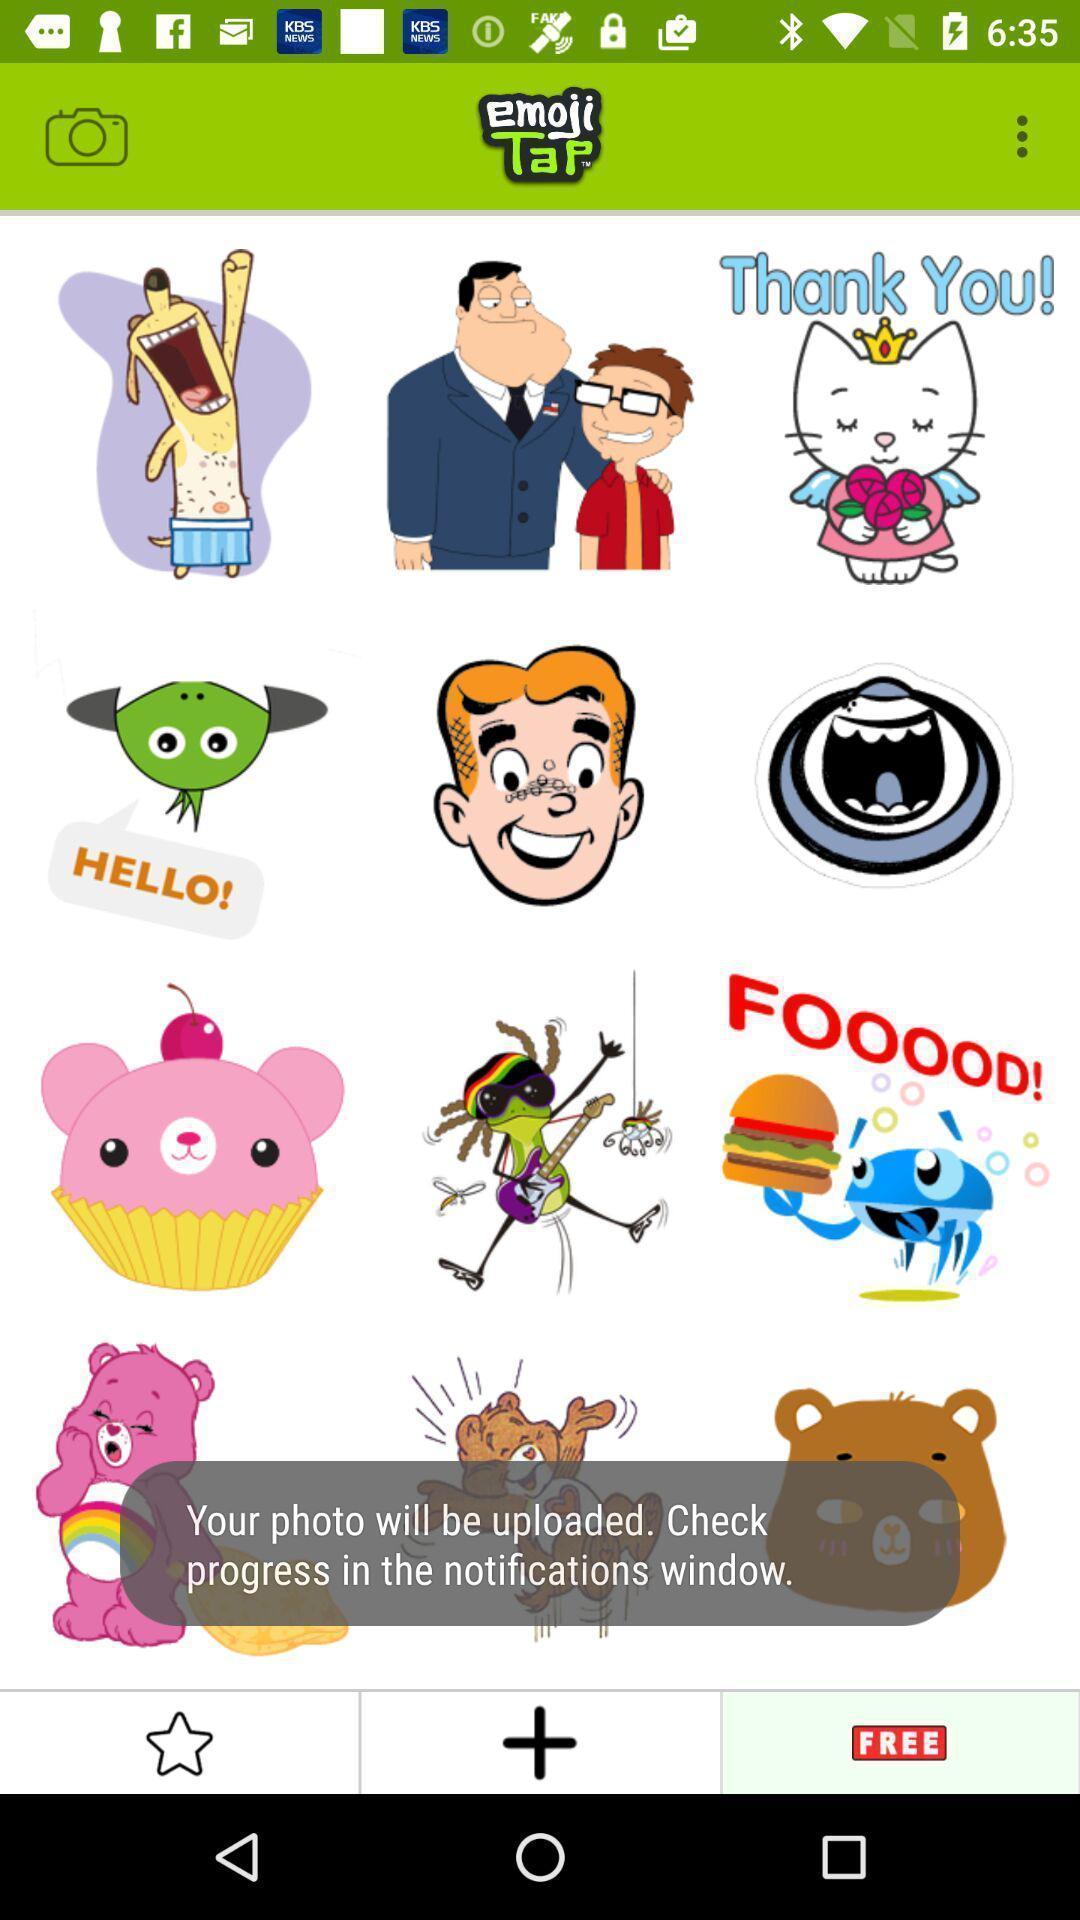Provide a detailed account of this screenshot. Pop up notification of an emoji app. 